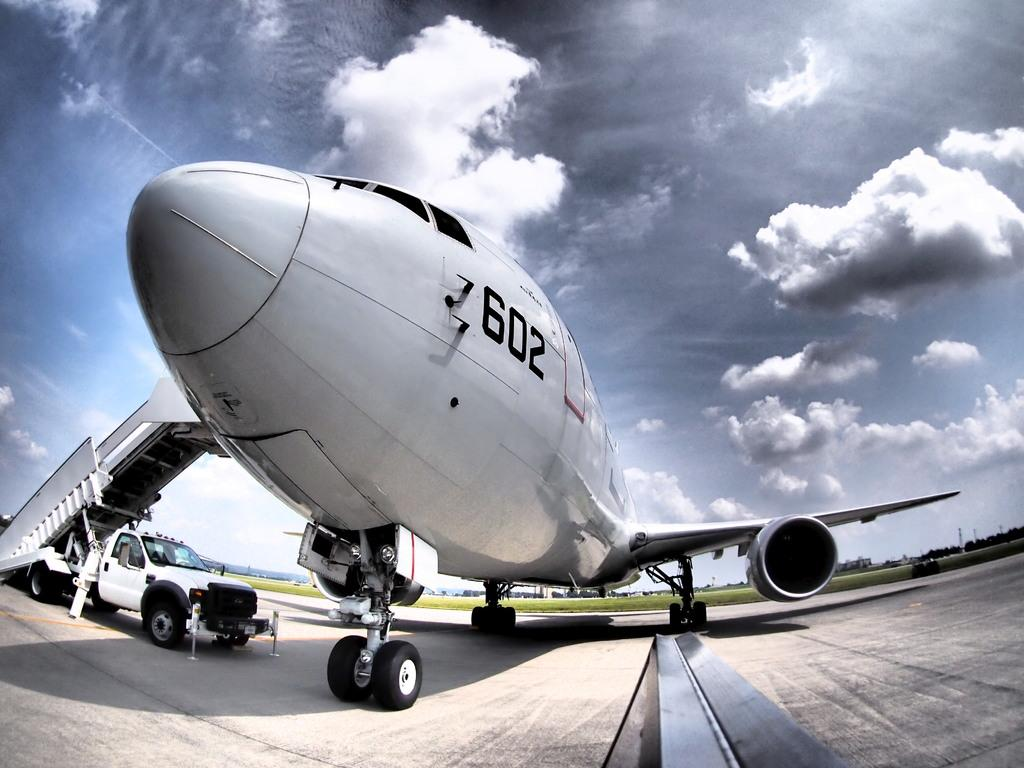<image>
Create a compact narrative representing the image presented. the number 602 on the side of a plane 